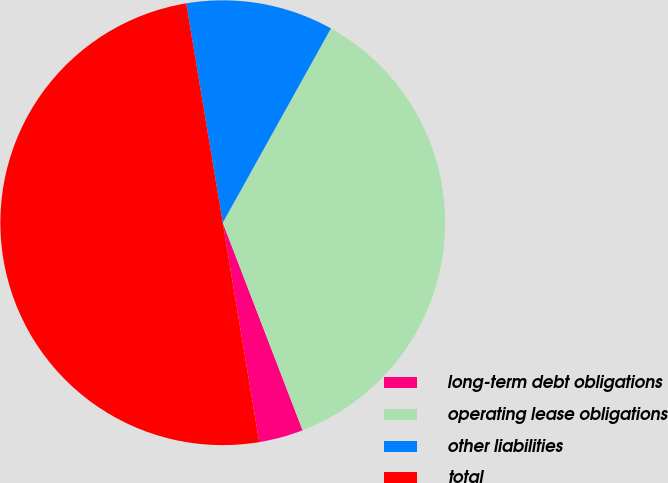Convert chart to OTSL. <chart><loc_0><loc_0><loc_500><loc_500><pie_chart><fcel>long-term debt obligations<fcel>operating lease obligations<fcel>other liabilities<fcel>total<nl><fcel>3.22%<fcel>36.07%<fcel>10.71%<fcel>50.0%<nl></chart> 